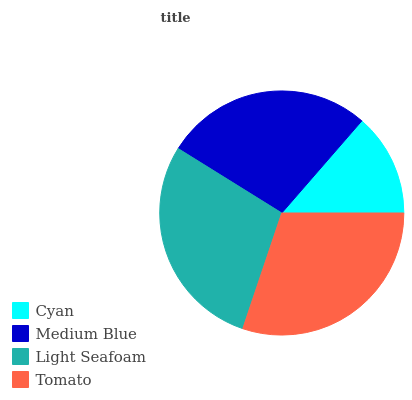Is Cyan the minimum?
Answer yes or no. Yes. Is Tomato the maximum?
Answer yes or no. Yes. Is Medium Blue the minimum?
Answer yes or no. No. Is Medium Blue the maximum?
Answer yes or no. No. Is Medium Blue greater than Cyan?
Answer yes or no. Yes. Is Cyan less than Medium Blue?
Answer yes or no. Yes. Is Cyan greater than Medium Blue?
Answer yes or no. No. Is Medium Blue less than Cyan?
Answer yes or no. No. Is Light Seafoam the high median?
Answer yes or no. Yes. Is Medium Blue the low median?
Answer yes or no. Yes. Is Tomato the high median?
Answer yes or no. No. Is Light Seafoam the low median?
Answer yes or no. No. 